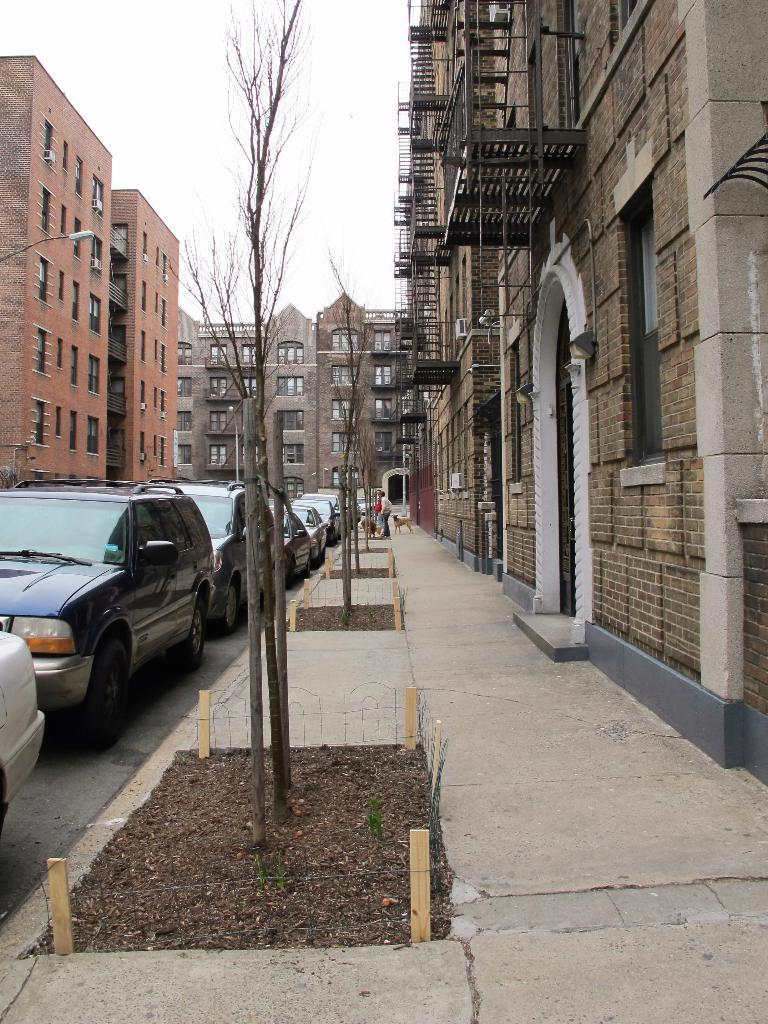What type of vehicles can be seen in the image? There are cars in the image. What structures are visible in the right corner of the image? There are buildings in the right corner of the image. What structures are visible in the left corner of the image? There are other buildings in the left corner of the image. What type of lunch is being served in the image? There is no lunch present in the image. What color is the car in the image? The provided facts do not mention the color of the cars in the image. 